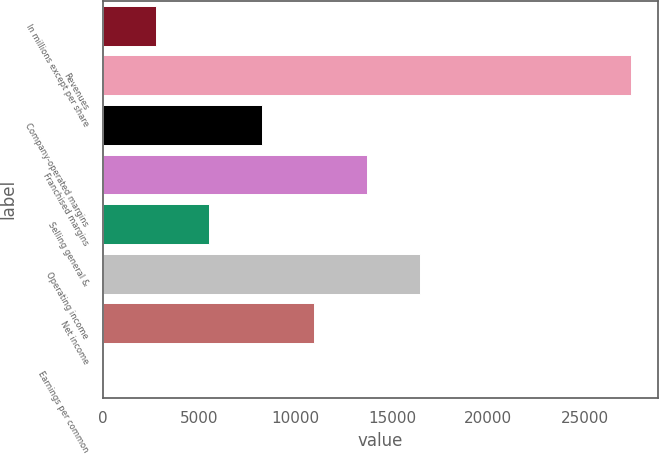<chart> <loc_0><loc_0><loc_500><loc_500><bar_chart><fcel>In millions except per share<fcel>Revenues<fcel>Company-operated margins<fcel>Franchised margins<fcel>Selling general &<fcel>Operating income<fcel>Net income<fcel>Earnings per common<nl><fcel>2748.44<fcel>27441<fcel>8235.68<fcel>13722.9<fcel>5492.06<fcel>16466.5<fcel>10979.3<fcel>4.82<nl></chart> 